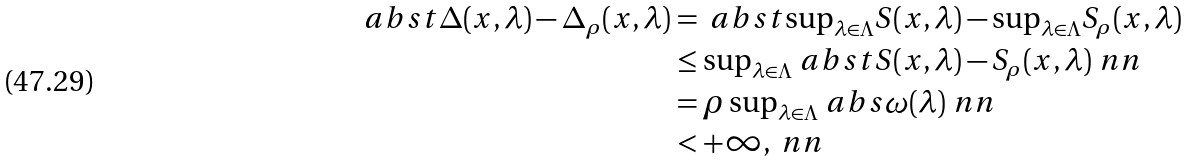<formula> <loc_0><loc_0><loc_500><loc_500>\ a b s t { \Delta ( x , \lambda ) - \Delta _ { \rho } ( x , \lambda ) } & = \ a b s t { { \sup } _ { \lambda \in \Lambda } S ( x , \lambda ) - { \sup } _ { \lambda \in \Lambda } S _ { \rho } ( x , \lambda ) } \\ & \leq { \sup } _ { \lambda \in \Lambda } \ a b s t { S ( x , \lambda ) - S _ { \rho } ( x , \lambda ) } \ n n \\ & = \rho \, { \sup } _ { \lambda \in \Lambda } \ a b s { \omega ( \lambda ) } \ n n \\ & < + \infty , \ n n</formula> 